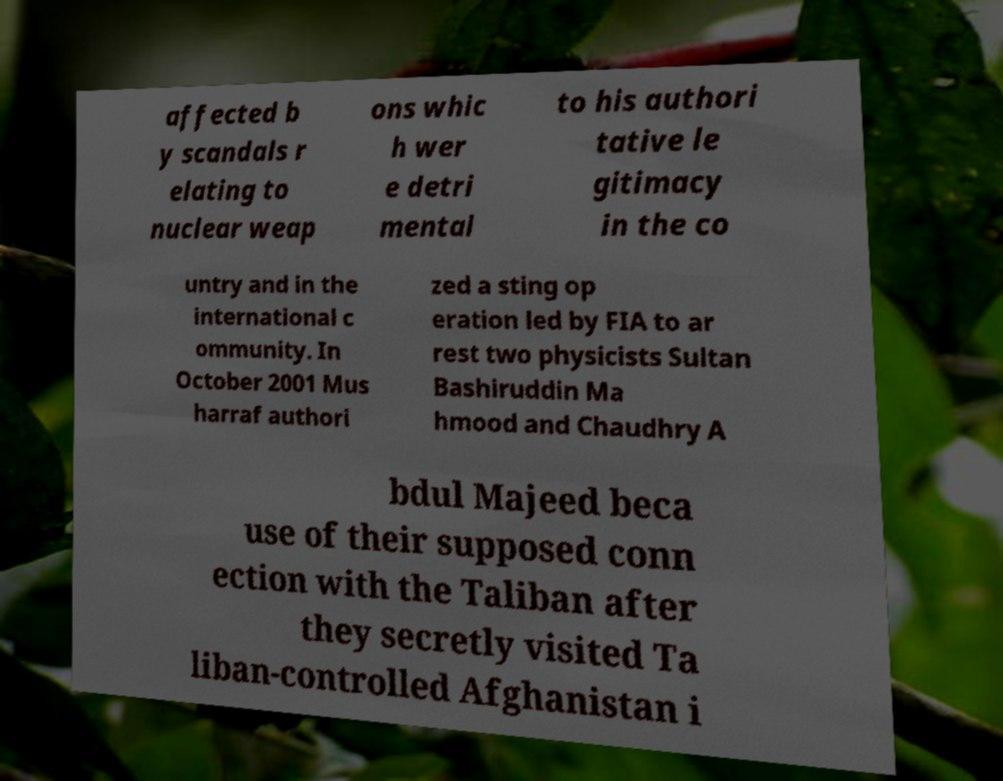Could you extract and type out the text from this image? affected b y scandals r elating to nuclear weap ons whic h wer e detri mental to his authori tative le gitimacy in the co untry and in the international c ommunity. In October 2001 Mus harraf authori zed a sting op eration led by FIA to ar rest two physicists Sultan Bashiruddin Ma hmood and Chaudhry A bdul Majeed beca use of their supposed conn ection with the Taliban after they secretly visited Ta liban-controlled Afghanistan i 